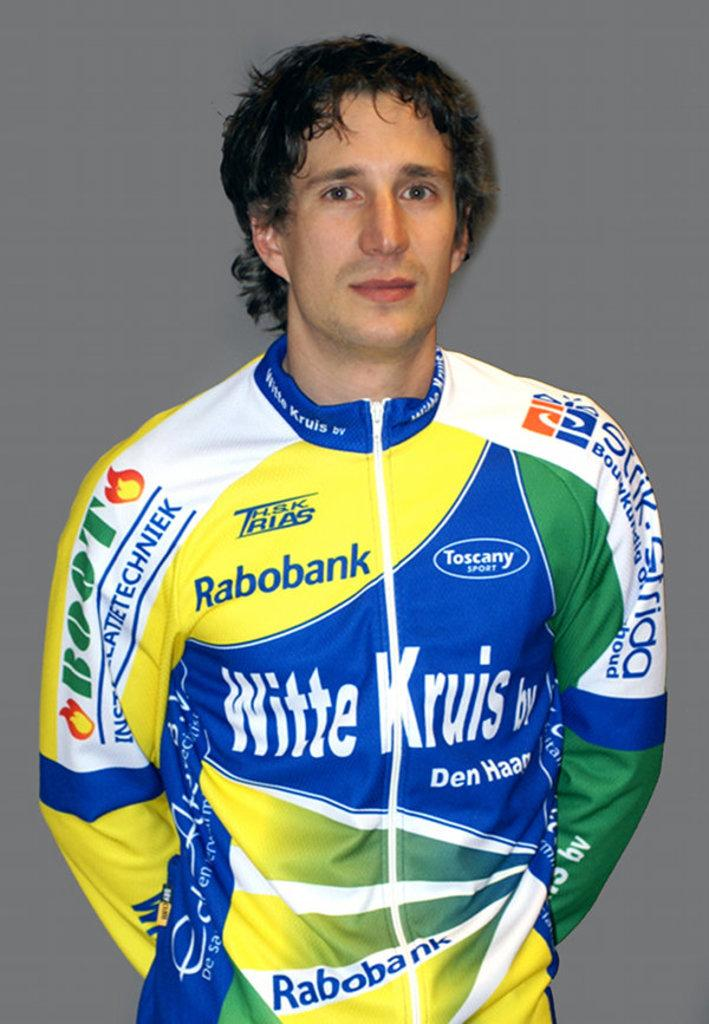Who is present in the image? There is a man in the image. What is the man doing in the image? The man is standing in the image. What is the man wearing in the image? The man is wearing a jacket in the image. What can be seen on the jacket? There are logos and names on the jacket. Can you tell me the order number for the jacket the man is wearing in the image? There is no order number visible in the image, as it only shows a man standing and wearing a jacket with logos and names. 